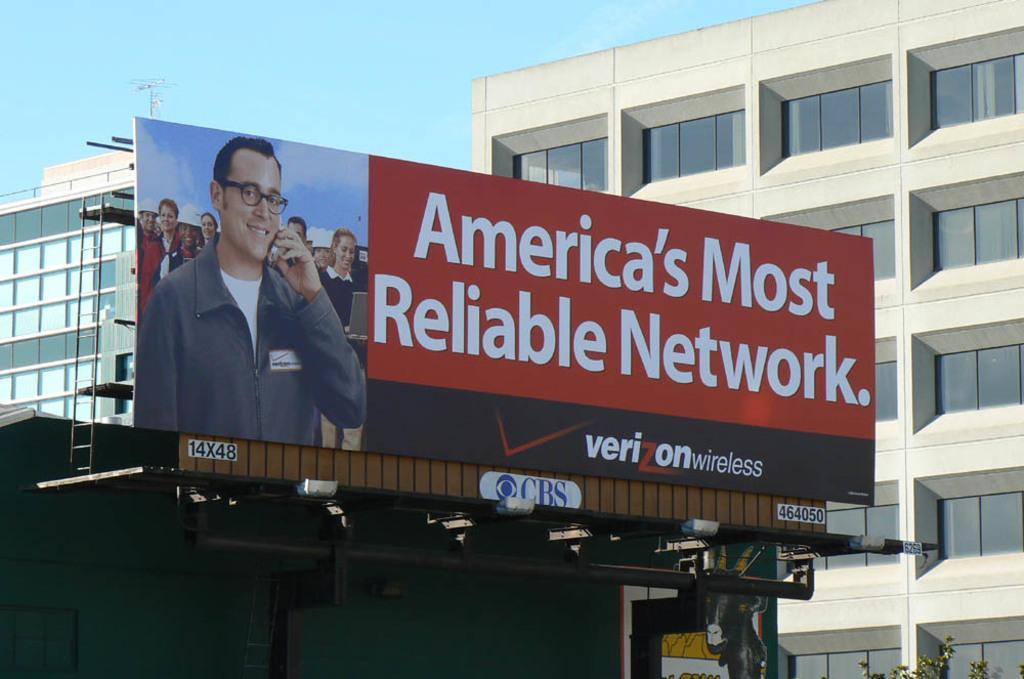Could you give a brief overview of what you see in this image? In the image there is an advertisement board and around that board there are some buildings. 